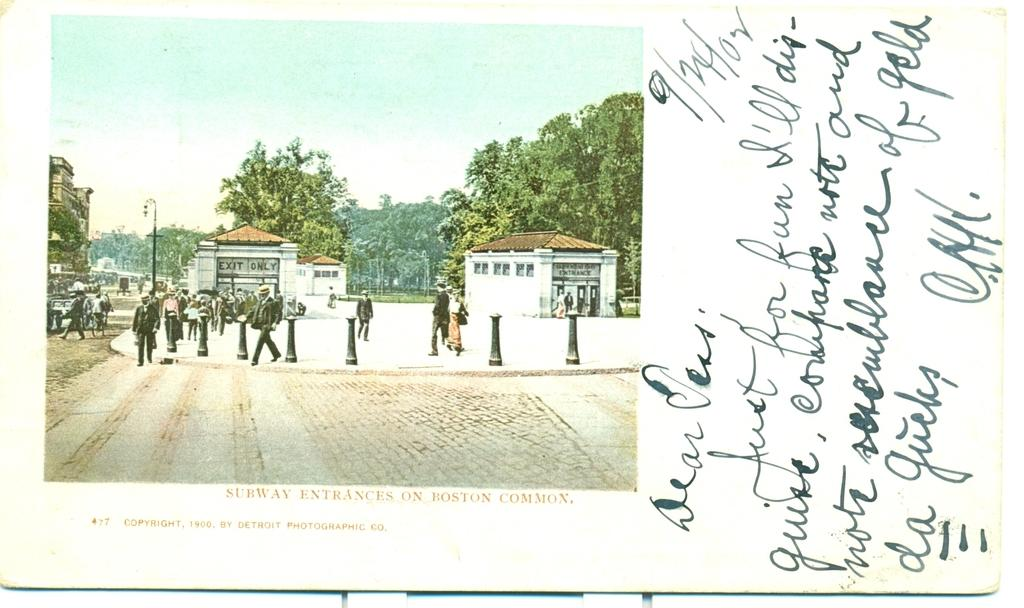Who or what can be seen in the image? There are people in the image. What structures are present in the image? There are buildings in the image. What type of lighting is visible in the image? There is a street lamp in the image. What type of vegetation is present in the image? There are trees in the image. What is visible in the background of the image? The sky is visible in the image. How many apples are hanging from the trees in the image? There are no apples present in the image; only trees are visible. What type of cat can be seen walking on the street lamp in the image? There is no cat present in the image; only people, buildings, a street lamp, trees, and the sky are visible. 